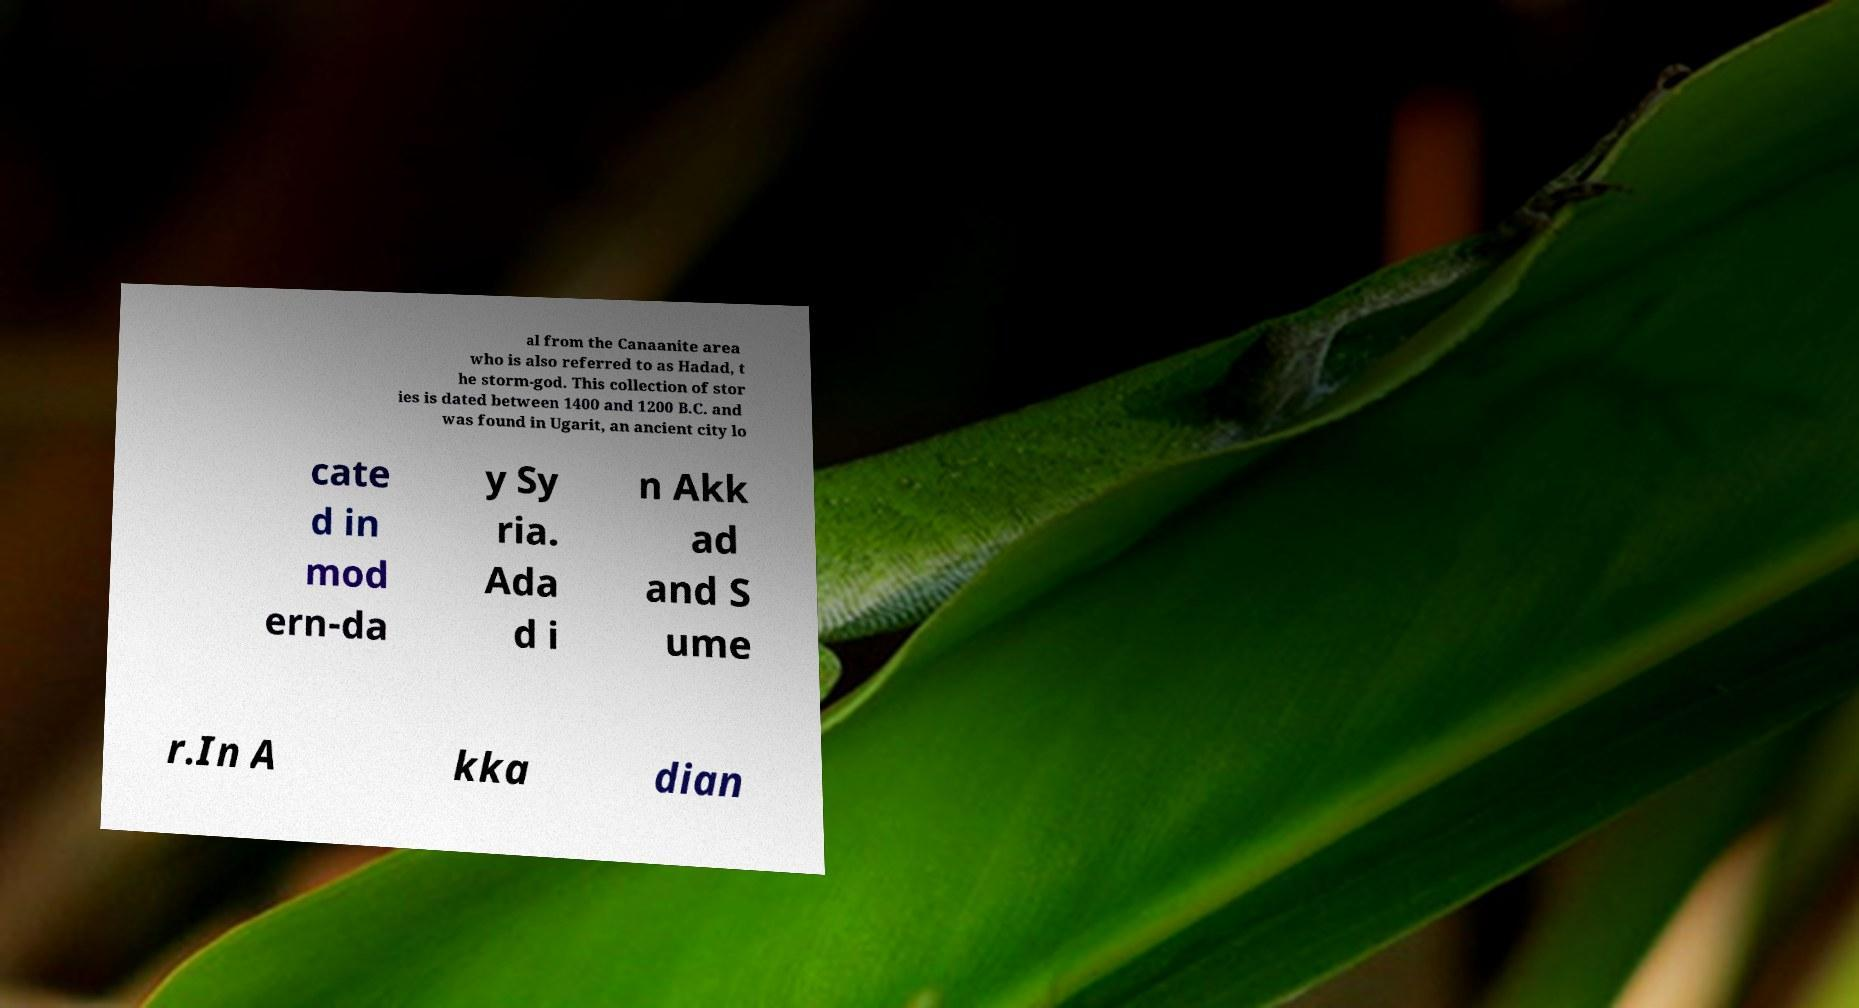I need the written content from this picture converted into text. Can you do that? al from the Canaanite area who is also referred to as Hadad, t he storm-god. This collection of stor ies is dated between 1400 and 1200 B.C. and was found in Ugarit, an ancient city lo cate d in mod ern-da y Sy ria. Ada d i n Akk ad and S ume r.In A kka dian 